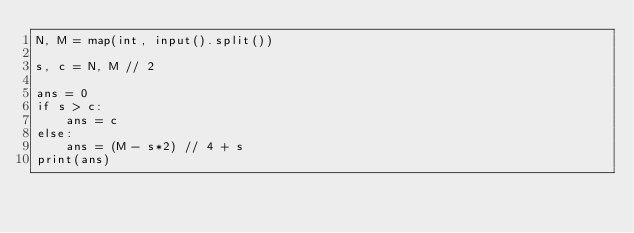Convert code to text. <code><loc_0><loc_0><loc_500><loc_500><_Python_>N, M = map(int, input().split())

s, c = N, M // 2

ans = 0
if s > c:
    ans = c
else:
    ans = (M - s*2) // 4 + s
print(ans)
</code> 